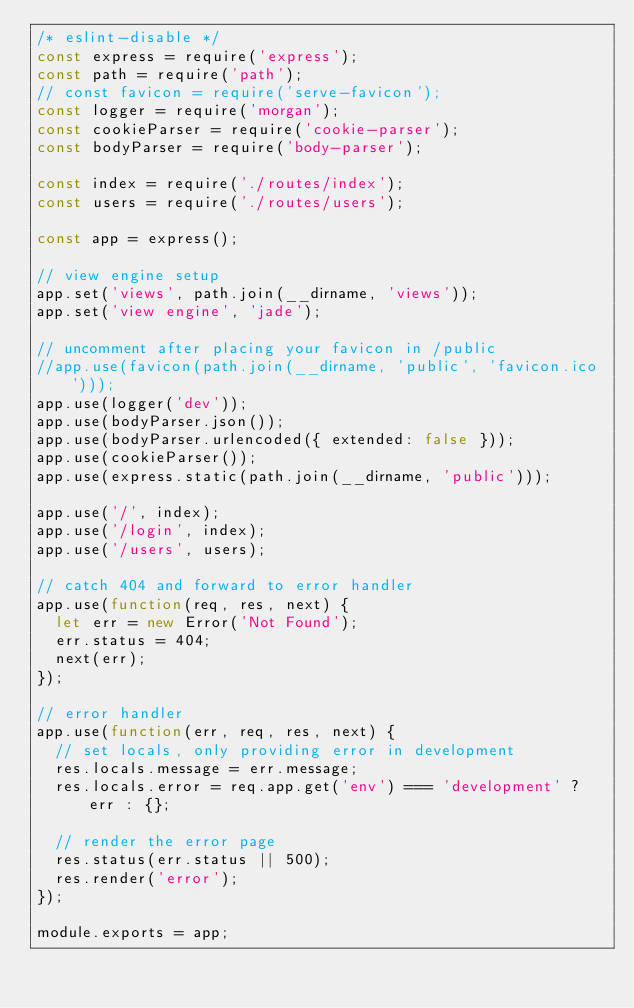Convert code to text. <code><loc_0><loc_0><loc_500><loc_500><_JavaScript_>/* eslint-disable */
const express = require('express');
const path = require('path');
// const favicon = require('serve-favicon');
const logger = require('morgan');
const cookieParser = require('cookie-parser');
const bodyParser = require('body-parser');

const index = require('./routes/index');
const users = require('./routes/users');

const app = express();

// view engine setup
app.set('views', path.join(__dirname, 'views'));
app.set('view engine', 'jade');

// uncomment after placing your favicon in /public
//app.use(favicon(path.join(__dirname, 'public', 'favicon.ico')));
app.use(logger('dev'));
app.use(bodyParser.json());
app.use(bodyParser.urlencoded({ extended: false }));
app.use(cookieParser());
app.use(express.static(path.join(__dirname, 'public')));

app.use('/', index);
app.use('/login', index);
app.use('/users', users);

// catch 404 and forward to error handler
app.use(function(req, res, next) {
  let err = new Error('Not Found');
  err.status = 404;
  next(err);
});

// error handler
app.use(function(err, req, res, next) {
  // set locals, only providing error in development
  res.locals.message = err.message;
  res.locals.error = req.app.get('env') === 'development' ? err : {};

  // render the error page
  res.status(err.status || 500);
  res.render('error');
});

module.exports = app;
</code> 